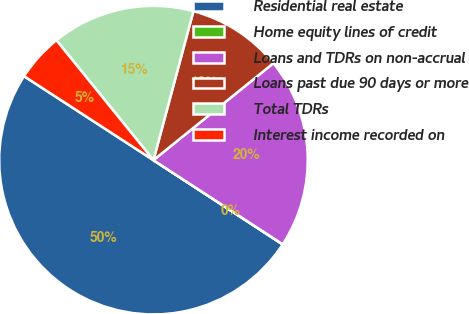Convert chart to OTSL. <chart><loc_0><loc_0><loc_500><loc_500><pie_chart><fcel>Residential real estate<fcel>Home equity lines of credit<fcel>Loans and TDRs on non-accrual<fcel>Loans past due 90 days or more<fcel>Total TDRs<fcel>Interest income recorded on<nl><fcel>49.97%<fcel>0.02%<fcel>20.0%<fcel>10.01%<fcel>15.0%<fcel>5.01%<nl></chart> 